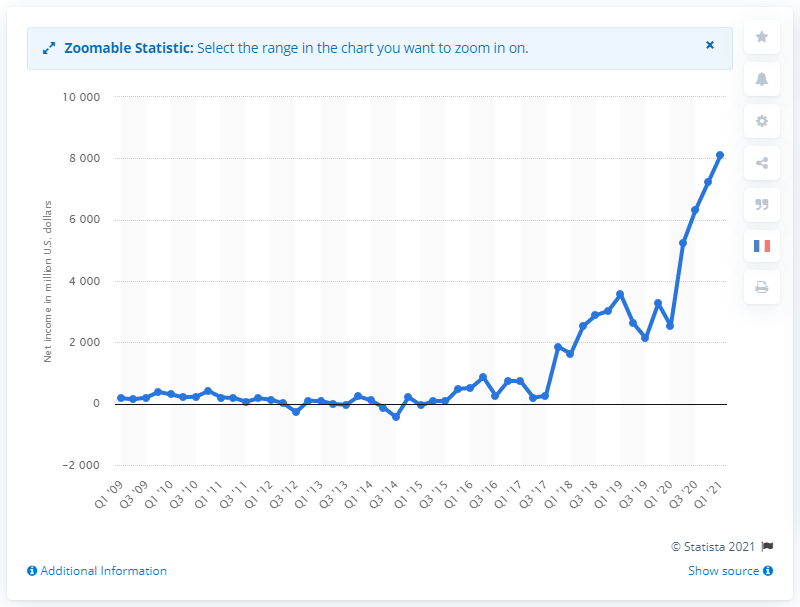List a handful of essential elements in this visual. Amazon's net income in the first quarter of 2021 was approximately $8,107 million. 